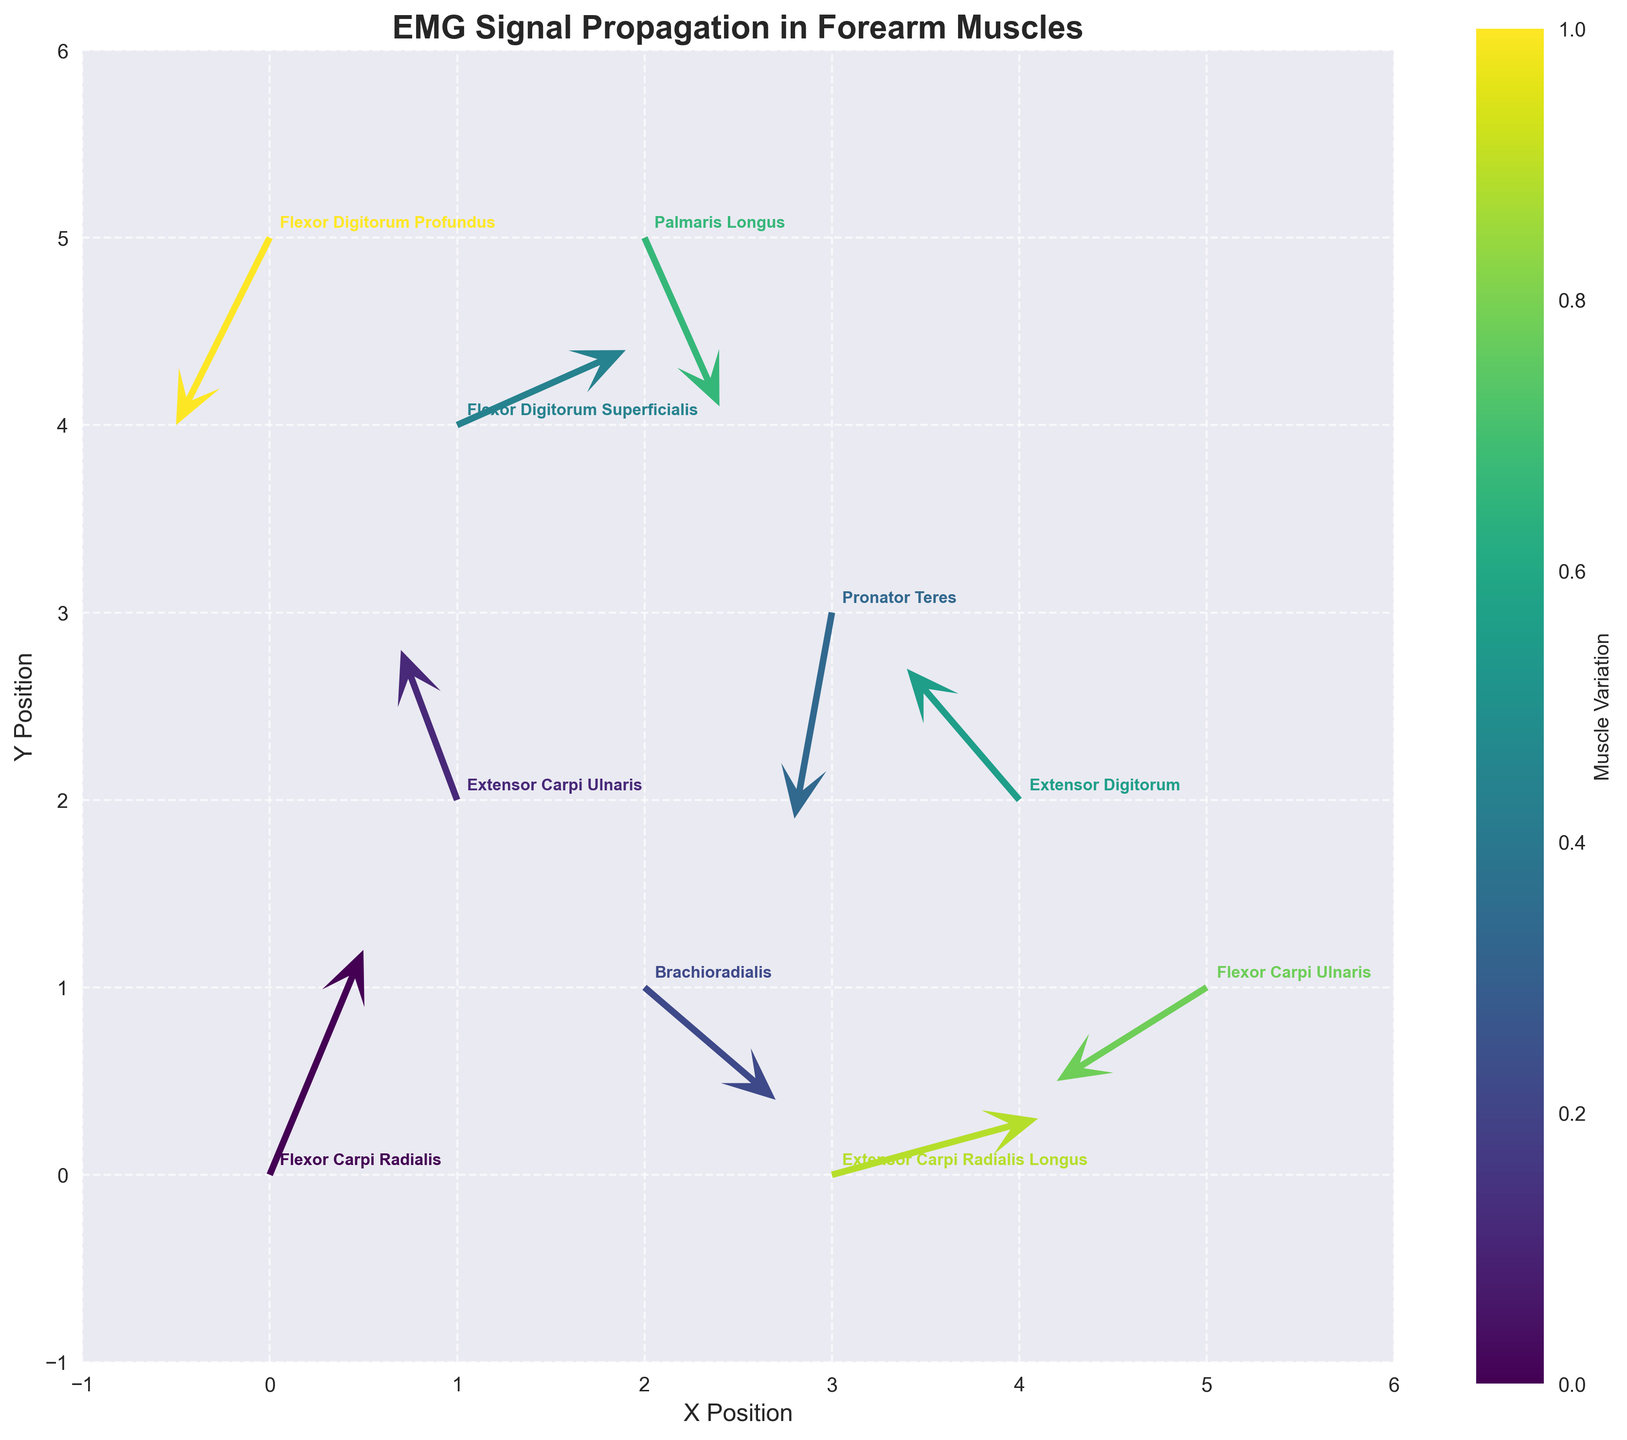What's the title of the plot? The title of the plot is usually displayed at the top and provides a brief description of the plot's purpose. Here it is "EMG Signal Propagation in Forearm Muscles"
Answer: EMG Signal Propagation in Forearm Muscles How many different muscles are represented in this plot? The plot annotates different arrows with muscle names. By counting the unique muscle names, we find there are 10 different muscles: Flexor Carpi Radialis, Extensor Carpi Ulnaris, Brachioradialis, Pronator Teres, Flexor Digitorum Superficialis, Extensor Digitorum, Palmaris Longus, Flexor Carpi Ulnaris, Extensor Carpi Radialis Longus, and Flexor Digitorum Profundus
Answer: 10 Which muscle shows the highest positive u component of the vector? The u component is the horizontal component of the vector. The muscle with the highest positive u component is Extensor Carpi Radialis Longus, represented by the vector starting at (3, 0) with a u component of 1.1
Answer: Extensor Carpi Radialis Longus What is the combined resultant vector magnitude of Flexor Digitorum Superficialis? To find the resultant vector magnitude, use the formula sqrt(u^2 + v^2). For Flexor Digitorum Superficialis (u=0.9, v=0.4), the magnitude is sqrt(0.9^2 + 0.4^2) = sqrt(0.81 + 0.16) = sqrt(0.97)
Answer: sqrt(0.97) Between Pronator Teres and Extensor Carpi Ulnaris, which muscle shows a greater resultant vector magnitude? For Pronator Teres: resultant magnitude = sqrt((-0.2)^2 + (-1.1)^2) = sqrt(0.04 + 1.21) = sqrt(1.25). For Extensor Carpi Ulnaris: resultant magnitude = sqrt((-0.3)^2 + 0.8^2) = sqrt(0.09 + 0.64) = sqrt(0.73). Pronator Teres has a greater magnitude
Answer: Pronator Teres Which muscle has the vector with the largest negative v component? The v component is the vertical component of the vector. The muscle with the largest negative v component is Flexor Carpi Ulnaris with a v component of -0.5, but we need the largest negative, which is Pronator Teres v=-1.1
Answer: Pronator Teres What is the orientation angle difference between the vectors of Flexor Carpi Radialis and Palmaris Longus? The vector angles can be calculated using atan2(v, u). For Flexor Carpi Radialis: angle = atan2(1.2, 0.5) ≈ 67.38°, and for Palmaris Longus: angle = atan2(-0.9, 0.4) ≈ -66.80°. The difference is 67.38° - (-66.80°) = 134.18°
Answer: 134.18° Which muscle's vector direction indicates the highest degree of upward movement (positive v direction)? The vector indicating the highest degree of upward movement is identified by the largest positive v component. Flexor Carpi Radialis with a v component of 1.2 is the highest positive v value in the dataset
Answer: Flexor Carpi Radialis What's the average of the horizontal (u) components for vectors starting from x=1? We look for vectors with x=1. There are three such vectors: Flexor Digitorum Superficialis (u=0.9), Extensor Carpi Ulnaris (u=-0.3), and Flexor Carpi Radialis (u=0.5). Average u = (0.9 + -0.3 + 0.5) / 3 = 1.1 / 3
Answer: 0.3667 Which two muscles have vectors starting at the same y-coordinate? Both vectors of Flexor Carpi Ulnaris and Extensor Carpi Radialis Longus start at y=1
Answer: Flexor Carpi Ulnaris and Extensor Carpi Radialis Longus 